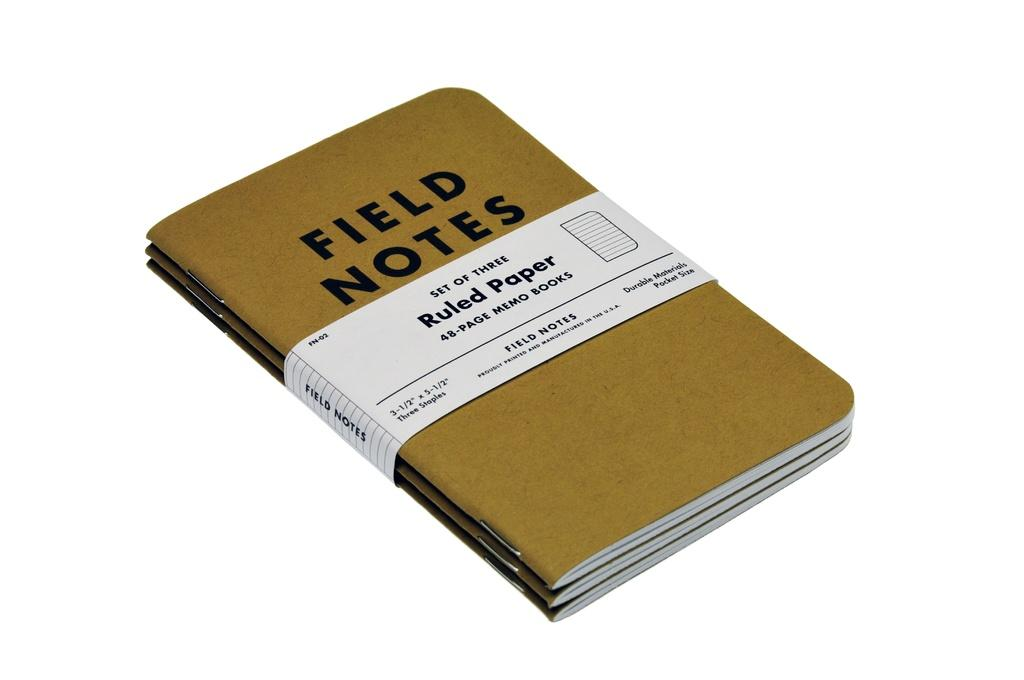<image>
Offer a succinct explanation of the picture presented. Three brown books called Field Notes are held together by a white piece of cardboard. 